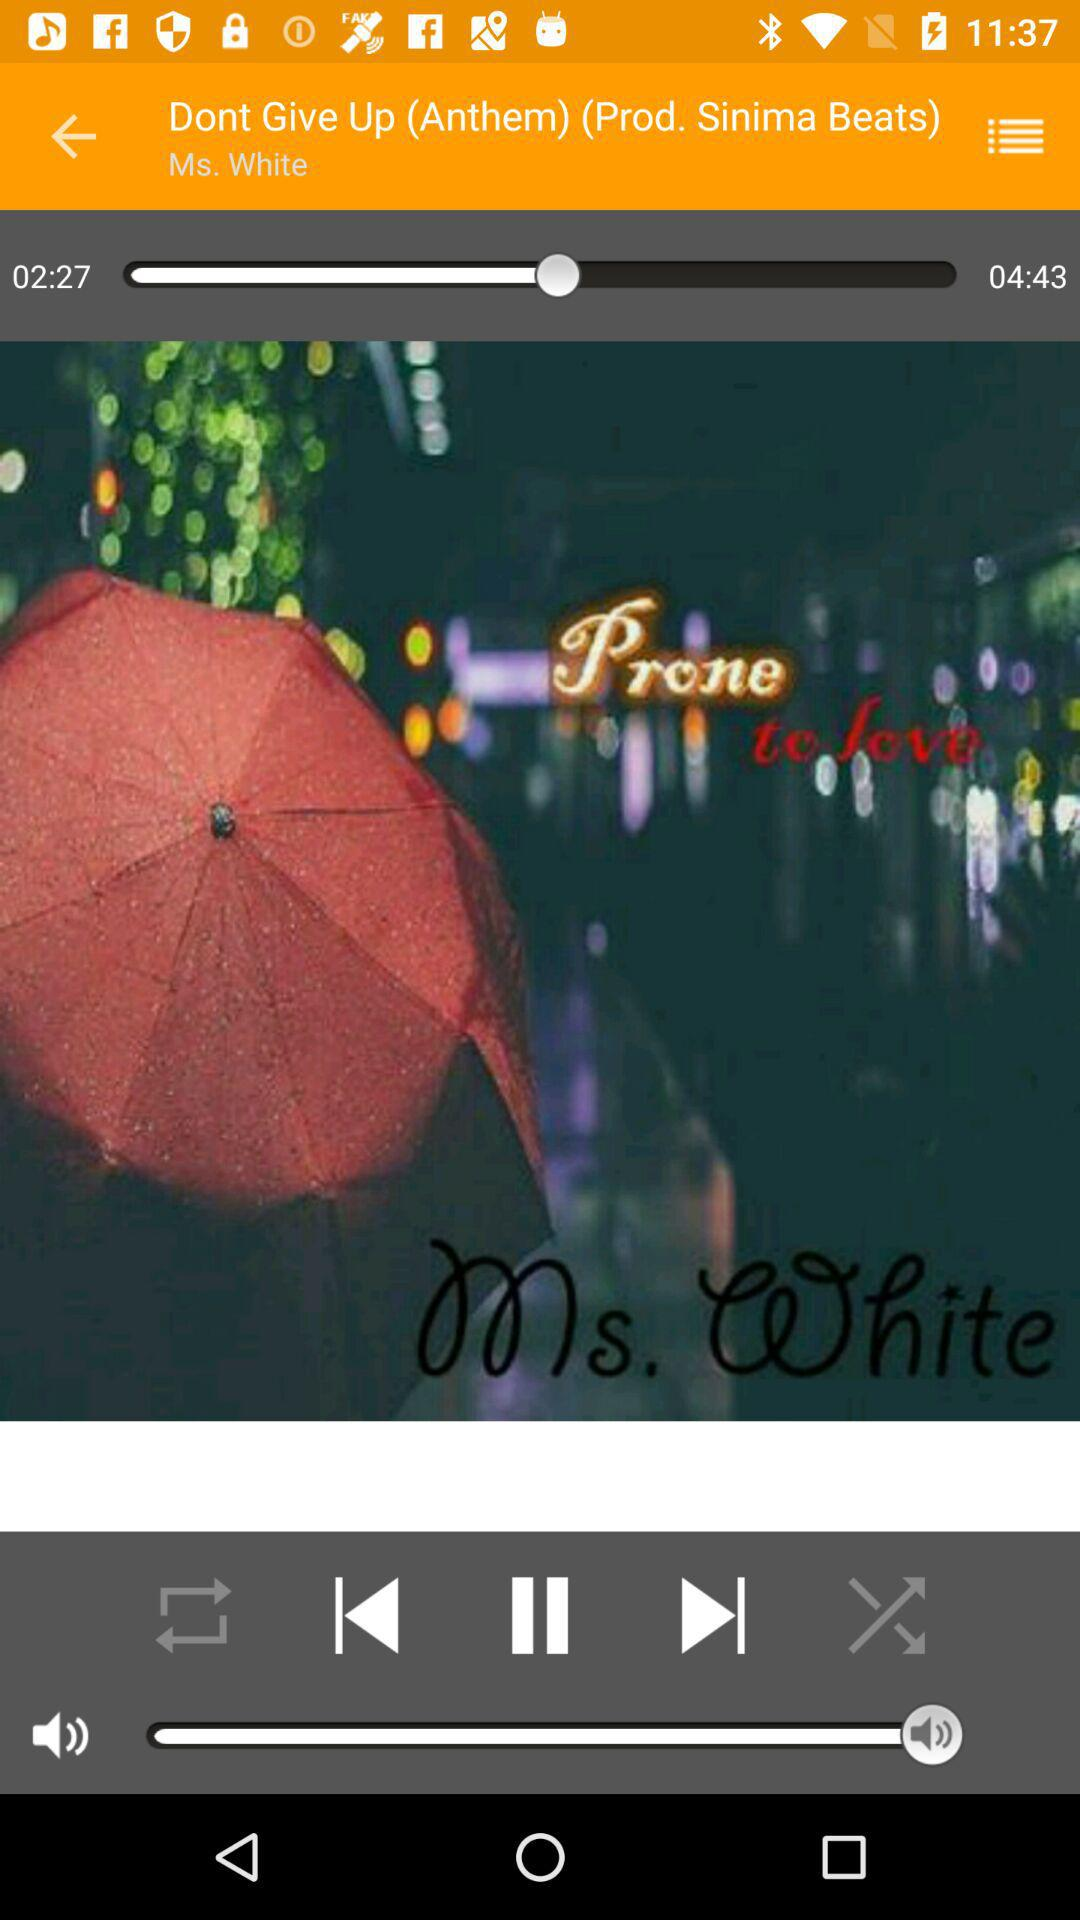What is the duration of the "Dont Give Up (Anthem)"? The duration is 04:43. 